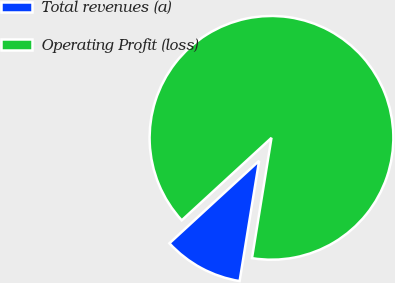Convert chart. <chart><loc_0><loc_0><loc_500><loc_500><pie_chart><fcel>Total revenues (a)<fcel>Operating Profit (loss)<nl><fcel>10.61%<fcel>89.39%<nl></chart> 